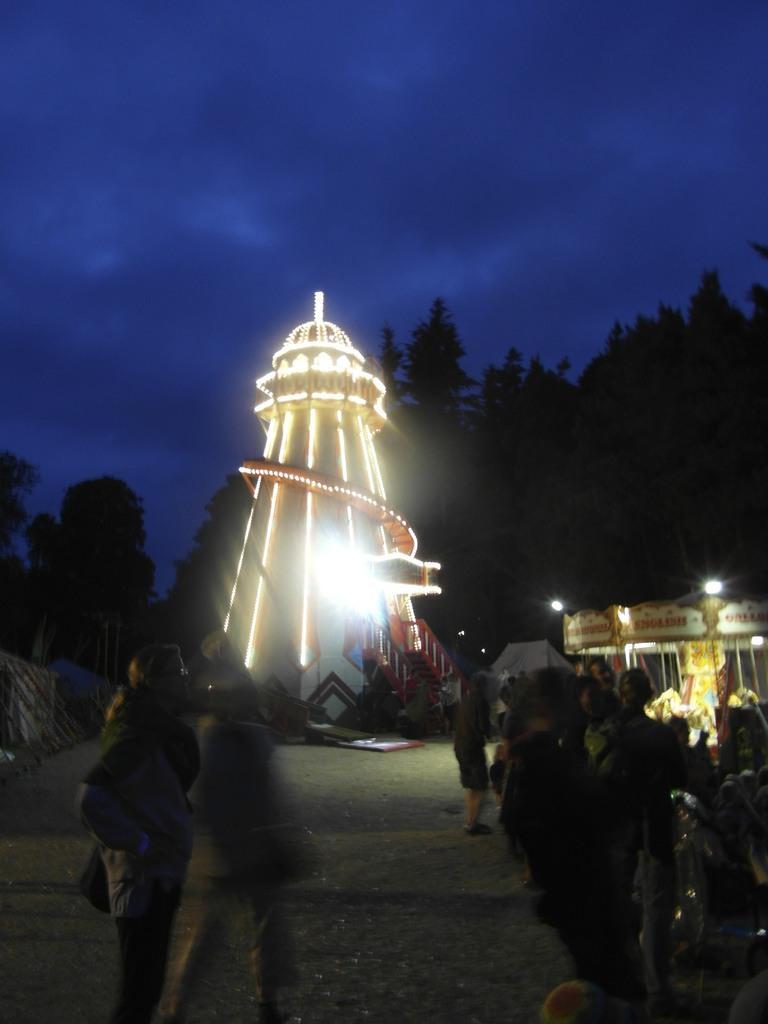How would you summarize this image in a sentence or two? In this image I can see the group of people with different color dresses. To the side I can see the tower and there are lights to it. To the side I can see the tent with lights. In the background there are trees and the blue sky. 